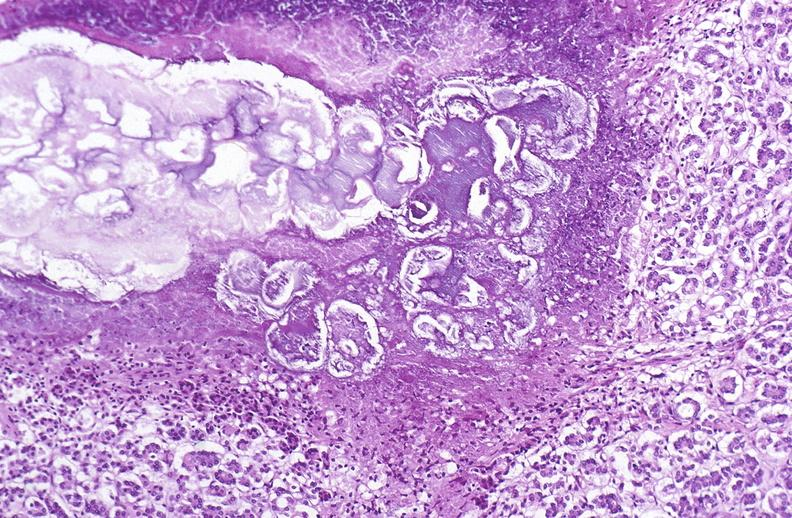does this image show pancreatic fat necrosis?
Answer the question using a single word or phrase. Yes 